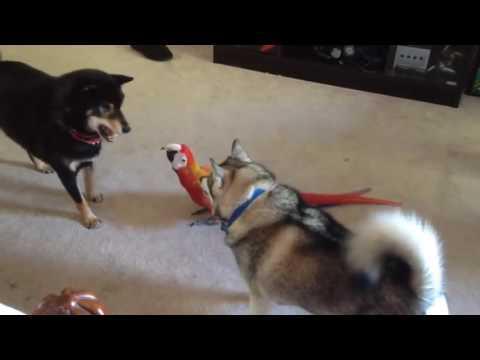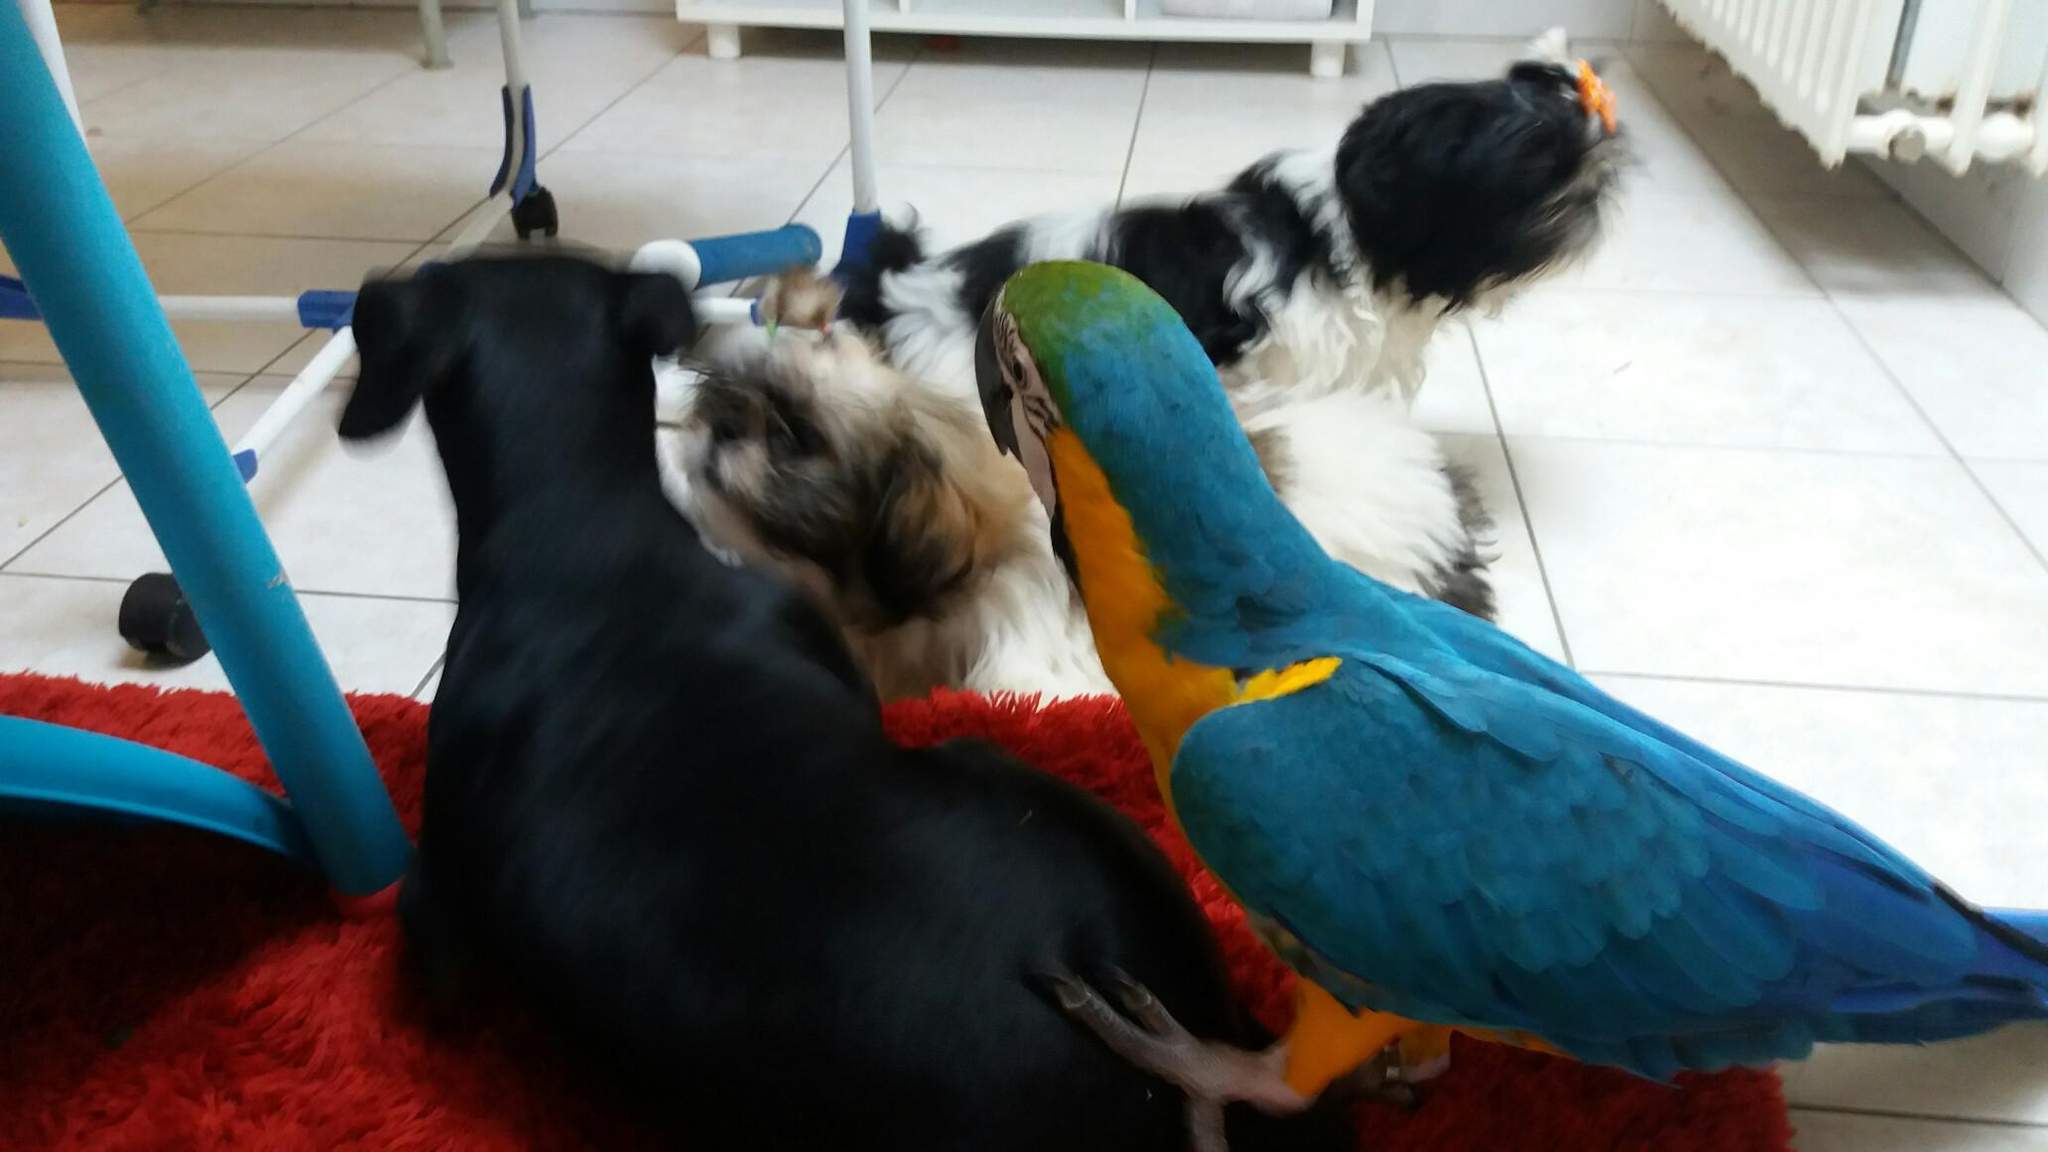The first image is the image on the left, the second image is the image on the right. For the images shown, is this caption "There are two dogs and a macaw standing on carpet together in one image." true? Answer yes or no. Yes. The first image is the image on the left, the second image is the image on the right. Considering the images on both sides, is "A german shepherd plays with a blue and gold macaw." valid? Answer yes or no. No. 